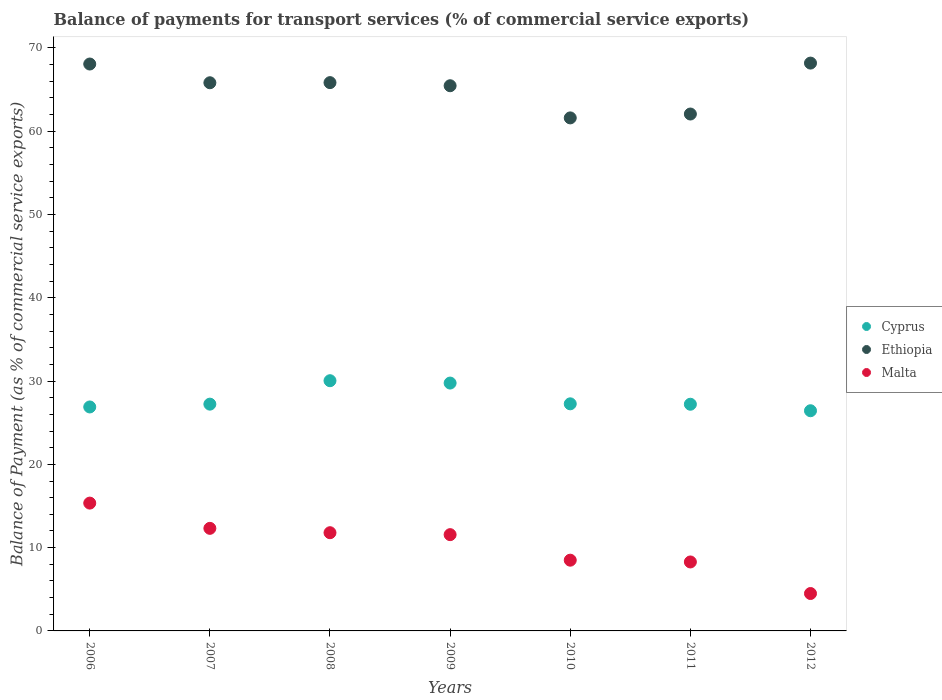How many different coloured dotlines are there?
Offer a very short reply. 3. What is the balance of payments for transport services in Malta in 2012?
Make the answer very short. 4.49. Across all years, what is the maximum balance of payments for transport services in Ethiopia?
Offer a very short reply. 68.18. Across all years, what is the minimum balance of payments for transport services in Ethiopia?
Your answer should be very brief. 61.6. In which year was the balance of payments for transport services in Malta maximum?
Offer a very short reply. 2006. What is the total balance of payments for transport services in Cyprus in the graph?
Keep it short and to the point. 194.86. What is the difference between the balance of payments for transport services in Malta in 2007 and that in 2008?
Your response must be concise. 0.52. What is the difference between the balance of payments for transport services in Malta in 2011 and the balance of payments for transport services in Ethiopia in 2012?
Give a very brief answer. -59.9. What is the average balance of payments for transport services in Ethiopia per year?
Make the answer very short. 65.29. In the year 2010, what is the difference between the balance of payments for transport services in Malta and balance of payments for transport services in Ethiopia?
Your answer should be very brief. -53.11. In how many years, is the balance of payments for transport services in Cyprus greater than 6 %?
Offer a terse response. 7. What is the ratio of the balance of payments for transport services in Cyprus in 2008 to that in 2010?
Provide a succinct answer. 1.1. Is the difference between the balance of payments for transport services in Malta in 2007 and 2011 greater than the difference between the balance of payments for transport services in Ethiopia in 2007 and 2011?
Make the answer very short. Yes. What is the difference between the highest and the second highest balance of payments for transport services in Ethiopia?
Provide a succinct answer. 0.11. What is the difference between the highest and the lowest balance of payments for transport services in Malta?
Provide a succinct answer. 10.86. Is the balance of payments for transport services in Malta strictly less than the balance of payments for transport services in Cyprus over the years?
Give a very brief answer. Yes. How many years are there in the graph?
Provide a short and direct response. 7. Does the graph contain any zero values?
Your answer should be compact. No. How are the legend labels stacked?
Your answer should be compact. Vertical. What is the title of the graph?
Ensure brevity in your answer.  Balance of payments for transport services (% of commercial service exports). Does "Botswana" appear as one of the legend labels in the graph?
Your answer should be very brief. No. What is the label or title of the X-axis?
Your answer should be compact. Years. What is the label or title of the Y-axis?
Your answer should be very brief. Balance of Payment (as % of commercial service exports). What is the Balance of Payment (as % of commercial service exports) in Cyprus in 2006?
Your answer should be compact. 26.89. What is the Balance of Payment (as % of commercial service exports) of Ethiopia in 2006?
Your answer should be very brief. 68.07. What is the Balance of Payment (as % of commercial service exports) in Malta in 2006?
Make the answer very short. 15.35. What is the Balance of Payment (as % of commercial service exports) in Cyprus in 2007?
Your answer should be compact. 27.23. What is the Balance of Payment (as % of commercial service exports) in Ethiopia in 2007?
Your answer should be very brief. 65.82. What is the Balance of Payment (as % of commercial service exports) in Malta in 2007?
Make the answer very short. 12.32. What is the Balance of Payment (as % of commercial service exports) in Cyprus in 2008?
Your answer should be compact. 30.05. What is the Balance of Payment (as % of commercial service exports) in Ethiopia in 2008?
Your answer should be compact. 65.84. What is the Balance of Payment (as % of commercial service exports) of Malta in 2008?
Offer a very short reply. 11.79. What is the Balance of Payment (as % of commercial service exports) in Cyprus in 2009?
Give a very brief answer. 29.76. What is the Balance of Payment (as % of commercial service exports) of Ethiopia in 2009?
Give a very brief answer. 65.47. What is the Balance of Payment (as % of commercial service exports) in Malta in 2009?
Keep it short and to the point. 11.56. What is the Balance of Payment (as % of commercial service exports) in Cyprus in 2010?
Keep it short and to the point. 27.27. What is the Balance of Payment (as % of commercial service exports) of Ethiopia in 2010?
Make the answer very short. 61.6. What is the Balance of Payment (as % of commercial service exports) in Malta in 2010?
Your answer should be compact. 8.49. What is the Balance of Payment (as % of commercial service exports) in Cyprus in 2011?
Give a very brief answer. 27.22. What is the Balance of Payment (as % of commercial service exports) in Ethiopia in 2011?
Your response must be concise. 62.07. What is the Balance of Payment (as % of commercial service exports) of Malta in 2011?
Provide a short and direct response. 8.28. What is the Balance of Payment (as % of commercial service exports) in Cyprus in 2012?
Ensure brevity in your answer.  26.44. What is the Balance of Payment (as % of commercial service exports) of Ethiopia in 2012?
Provide a short and direct response. 68.18. What is the Balance of Payment (as % of commercial service exports) of Malta in 2012?
Offer a very short reply. 4.49. Across all years, what is the maximum Balance of Payment (as % of commercial service exports) in Cyprus?
Keep it short and to the point. 30.05. Across all years, what is the maximum Balance of Payment (as % of commercial service exports) of Ethiopia?
Your answer should be very brief. 68.18. Across all years, what is the maximum Balance of Payment (as % of commercial service exports) of Malta?
Keep it short and to the point. 15.35. Across all years, what is the minimum Balance of Payment (as % of commercial service exports) of Cyprus?
Ensure brevity in your answer.  26.44. Across all years, what is the minimum Balance of Payment (as % of commercial service exports) of Ethiopia?
Give a very brief answer. 61.6. Across all years, what is the minimum Balance of Payment (as % of commercial service exports) of Malta?
Offer a very short reply. 4.49. What is the total Balance of Payment (as % of commercial service exports) of Cyprus in the graph?
Provide a succinct answer. 194.86. What is the total Balance of Payment (as % of commercial service exports) of Ethiopia in the graph?
Keep it short and to the point. 457.06. What is the total Balance of Payment (as % of commercial service exports) of Malta in the graph?
Provide a succinct answer. 72.29. What is the difference between the Balance of Payment (as % of commercial service exports) in Cyprus in 2006 and that in 2007?
Make the answer very short. -0.34. What is the difference between the Balance of Payment (as % of commercial service exports) in Ethiopia in 2006 and that in 2007?
Your answer should be very brief. 2.25. What is the difference between the Balance of Payment (as % of commercial service exports) of Malta in 2006 and that in 2007?
Offer a terse response. 3.03. What is the difference between the Balance of Payment (as % of commercial service exports) in Cyprus in 2006 and that in 2008?
Offer a very short reply. -3.15. What is the difference between the Balance of Payment (as % of commercial service exports) of Ethiopia in 2006 and that in 2008?
Your answer should be very brief. 2.23. What is the difference between the Balance of Payment (as % of commercial service exports) of Malta in 2006 and that in 2008?
Keep it short and to the point. 3.55. What is the difference between the Balance of Payment (as % of commercial service exports) in Cyprus in 2006 and that in 2009?
Make the answer very short. -2.87. What is the difference between the Balance of Payment (as % of commercial service exports) of Ethiopia in 2006 and that in 2009?
Your answer should be compact. 2.61. What is the difference between the Balance of Payment (as % of commercial service exports) in Malta in 2006 and that in 2009?
Keep it short and to the point. 3.79. What is the difference between the Balance of Payment (as % of commercial service exports) in Cyprus in 2006 and that in 2010?
Provide a short and direct response. -0.38. What is the difference between the Balance of Payment (as % of commercial service exports) in Ethiopia in 2006 and that in 2010?
Make the answer very short. 6.47. What is the difference between the Balance of Payment (as % of commercial service exports) of Malta in 2006 and that in 2010?
Your answer should be compact. 6.85. What is the difference between the Balance of Payment (as % of commercial service exports) in Cyprus in 2006 and that in 2011?
Provide a succinct answer. -0.33. What is the difference between the Balance of Payment (as % of commercial service exports) in Ethiopia in 2006 and that in 2011?
Give a very brief answer. 6. What is the difference between the Balance of Payment (as % of commercial service exports) of Malta in 2006 and that in 2011?
Your response must be concise. 7.07. What is the difference between the Balance of Payment (as % of commercial service exports) in Cyprus in 2006 and that in 2012?
Offer a very short reply. 0.45. What is the difference between the Balance of Payment (as % of commercial service exports) of Ethiopia in 2006 and that in 2012?
Provide a succinct answer. -0.11. What is the difference between the Balance of Payment (as % of commercial service exports) of Malta in 2006 and that in 2012?
Give a very brief answer. 10.86. What is the difference between the Balance of Payment (as % of commercial service exports) of Cyprus in 2007 and that in 2008?
Provide a short and direct response. -2.81. What is the difference between the Balance of Payment (as % of commercial service exports) of Ethiopia in 2007 and that in 2008?
Your answer should be very brief. -0.02. What is the difference between the Balance of Payment (as % of commercial service exports) in Malta in 2007 and that in 2008?
Provide a succinct answer. 0.52. What is the difference between the Balance of Payment (as % of commercial service exports) in Cyprus in 2007 and that in 2009?
Ensure brevity in your answer.  -2.53. What is the difference between the Balance of Payment (as % of commercial service exports) in Ethiopia in 2007 and that in 2009?
Keep it short and to the point. 0.36. What is the difference between the Balance of Payment (as % of commercial service exports) of Malta in 2007 and that in 2009?
Provide a short and direct response. 0.76. What is the difference between the Balance of Payment (as % of commercial service exports) in Cyprus in 2007 and that in 2010?
Offer a terse response. -0.04. What is the difference between the Balance of Payment (as % of commercial service exports) of Ethiopia in 2007 and that in 2010?
Ensure brevity in your answer.  4.22. What is the difference between the Balance of Payment (as % of commercial service exports) of Malta in 2007 and that in 2010?
Provide a short and direct response. 3.82. What is the difference between the Balance of Payment (as % of commercial service exports) of Cyprus in 2007 and that in 2011?
Your answer should be very brief. 0.01. What is the difference between the Balance of Payment (as % of commercial service exports) of Ethiopia in 2007 and that in 2011?
Provide a short and direct response. 3.75. What is the difference between the Balance of Payment (as % of commercial service exports) in Malta in 2007 and that in 2011?
Your response must be concise. 4.04. What is the difference between the Balance of Payment (as % of commercial service exports) in Cyprus in 2007 and that in 2012?
Give a very brief answer. 0.79. What is the difference between the Balance of Payment (as % of commercial service exports) of Ethiopia in 2007 and that in 2012?
Offer a terse response. -2.36. What is the difference between the Balance of Payment (as % of commercial service exports) in Malta in 2007 and that in 2012?
Keep it short and to the point. 7.83. What is the difference between the Balance of Payment (as % of commercial service exports) of Cyprus in 2008 and that in 2009?
Your answer should be compact. 0.28. What is the difference between the Balance of Payment (as % of commercial service exports) in Ethiopia in 2008 and that in 2009?
Offer a terse response. 0.37. What is the difference between the Balance of Payment (as % of commercial service exports) of Malta in 2008 and that in 2009?
Keep it short and to the point. 0.23. What is the difference between the Balance of Payment (as % of commercial service exports) in Cyprus in 2008 and that in 2010?
Your answer should be very brief. 2.78. What is the difference between the Balance of Payment (as % of commercial service exports) in Ethiopia in 2008 and that in 2010?
Provide a succinct answer. 4.24. What is the difference between the Balance of Payment (as % of commercial service exports) in Malta in 2008 and that in 2010?
Make the answer very short. 3.3. What is the difference between the Balance of Payment (as % of commercial service exports) in Cyprus in 2008 and that in 2011?
Your answer should be compact. 2.83. What is the difference between the Balance of Payment (as % of commercial service exports) of Ethiopia in 2008 and that in 2011?
Keep it short and to the point. 3.77. What is the difference between the Balance of Payment (as % of commercial service exports) of Malta in 2008 and that in 2011?
Your answer should be compact. 3.51. What is the difference between the Balance of Payment (as % of commercial service exports) of Cyprus in 2008 and that in 2012?
Offer a terse response. 3.61. What is the difference between the Balance of Payment (as % of commercial service exports) of Ethiopia in 2008 and that in 2012?
Ensure brevity in your answer.  -2.34. What is the difference between the Balance of Payment (as % of commercial service exports) of Malta in 2008 and that in 2012?
Provide a short and direct response. 7.3. What is the difference between the Balance of Payment (as % of commercial service exports) of Cyprus in 2009 and that in 2010?
Provide a succinct answer. 2.49. What is the difference between the Balance of Payment (as % of commercial service exports) of Ethiopia in 2009 and that in 2010?
Provide a succinct answer. 3.86. What is the difference between the Balance of Payment (as % of commercial service exports) of Malta in 2009 and that in 2010?
Give a very brief answer. 3.07. What is the difference between the Balance of Payment (as % of commercial service exports) of Cyprus in 2009 and that in 2011?
Offer a terse response. 2.54. What is the difference between the Balance of Payment (as % of commercial service exports) of Ethiopia in 2009 and that in 2011?
Provide a short and direct response. 3.4. What is the difference between the Balance of Payment (as % of commercial service exports) in Malta in 2009 and that in 2011?
Provide a short and direct response. 3.28. What is the difference between the Balance of Payment (as % of commercial service exports) in Cyprus in 2009 and that in 2012?
Your answer should be compact. 3.32. What is the difference between the Balance of Payment (as % of commercial service exports) in Ethiopia in 2009 and that in 2012?
Make the answer very short. -2.72. What is the difference between the Balance of Payment (as % of commercial service exports) in Malta in 2009 and that in 2012?
Provide a short and direct response. 7.07. What is the difference between the Balance of Payment (as % of commercial service exports) in Cyprus in 2010 and that in 2011?
Offer a very short reply. 0.05. What is the difference between the Balance of Payment (as % of commercial service exports) of Ethiopia in 2010 and that in 2011?
Offer a terse response. -0.46. What is the difference between the Balance of Payment (as % of commercial service exports) of Malta in 2010 and that in 2011?
Your answer should be very brief. 0.21. What is the difference between the Balance of Payment (as % of commercial service exports) in Cyprus in 2010 and that in 2012?
Your answer should be very brief. 0.83. What is the difference between the Balance of Payment (as % of commercial service exports) in Ethiopia in 2010 and that in 2012?
Your answer should be very brief. -6.58. What is the difference between the Balance of Payment (as % of commercial service exports) of Malta in 2010 and that in 2012?
Ensure brevity in your answer.  4. What is the difference between the Balance of Payment (as % of commercial service exports) in Cyprus in 2011 and that in 2012?
Ensure brevity in your answer.  0.78. What is the difference between the Balance of Payment (as % of commercial service exports) of Ethiopia in 2011 and that in 2012?
Ensure brevity in your answer.  -6.12. What is the difference between the Balance of Payment (as % of commercial service exports) of Malta in 2011 and that in 2012?
Provide a short and direct response. 3.79. What is the difference between the Balance of Payment (as % of commercial service exports) of Cyprus in 2006 and the Balance of Payment (as % of commercial service exports) of Ethiopia in 2007?
Give a very brief answer. -38.93. What is the difference between the Balance of Payment (as % of commercial service exports) in Cyprus in 2006 and the Balance of Payment (as % of commercial service exports) in Malta in 2007?
Provide a short and direct response. 14.58. What is the difference between the Balance of Payment (as % of commercial service exports) in Ethiopia in 2006 and the Balance of Payment (as % of commercial service exports) in Malta in 2007?
Ensure brevity in your answer.  55.76. What is the difference between the Balance of Payment (as % of commercial service exports) of Cyprus in 2006 and the Balance of Payment (as % of commercial service exports) of Ethiopia in 2008?
Your answer should be very brief. -38.95. What is the difference between the Balance of Payment (as % of commercial service exports) in Cyprus in 2006 and the Balance of Payment (as % of commercial service exports) in Malta in 2008?
Provide a short and direct response. 15.1. What is the difference between the Balance of Payment (as % of commercial service exports) of Ethiopia in 2006 and the Balance of Payment (as % of commercial service exports) of Malta in 2008?
Offer a terse response. 56.28. What is the difference between the Balance of Payment (as % of commercial service exports) in Cyprus in 2006 and the Balance of Payment (as % of commercial service exports) in Ethiopia in 2009?
Provide a succinct answer. -38.57. What is the difference between the Balance of Payment (as % of commercial service exports) of Cyprus in 2006 and the Balance of Payment (as % of commercial service exports) of Malta in 2009?
Offer a terse response. 15.33. What is the difference between the Balance of Payment (as % of commercial service exports) of Ethiopia in 2006 and the Balance of Payment (as % of commercial service exports) of Malta in 2009?
Offer a terse response. 56.51. What is the difference between the Balance of Payment (as % of commercial service exports) in Cyprus in 2006 and the Balance of Payment (as % of commercial service exports) in Ethiopia in 2010?
Your response must be concise. -34.71. What is the difference between the Balance of Payment (as % of commercial service exports) in Cyprus in 2006 and the Balance of Payment (as % of commercial service exports) in Malta in 2010?
Offer a very short reply. 18.4. What is the difference between the Balance of Payment (as % of commercial service exports) of Ethiopia in 2006 and the Balance of Payment (as % of commercial service exports) of Malta in 2010?
Keep it short and to the point. 59.58. What is the difference between the Balance of Payment (as % of commercial service exports) in Cyprus in 2006 and the Balance of Payment (as % of commercial service exports) in Ethiopia in 2011?
Offer a very short reply. -35.18. What is the difference between the Balance of Payment (as % of commercial service exports) in Cyprus in 2006 and the Balance of Payment (as % of commercial service exports) in Malta in 2011?
Your answer should be compact. 18.61. What is the difference between the Balance of Payment (as % of commercial service exports) in Ethiopia in 2006 and the Balance of Payment (as % of commercial service exports) in Malta in 2011?
Give a very brief answer. 59.79. What is the difference between the Balance of Payment (as % of commercial service exports) in Cyprus in 2006 and the Balance of Payment (as % of commercial service exports) in Ethiopia in 2012?
Give a very brief answer. -41.29. What is the difference between the Balance of Payment (as % of commercial service exports) in Cyprus in 2006 and the Balance of Payment (as % of commercial service exports) in Malta in 2012?
Your response must be concise. 22.4. What is the difference between the Balance of Payment (as % of commercial service exports) in Ethiopia in 2006 and the Balance of Payment (as % of commercial service exports) in Malta in 2012?
Give a very brief answer. 63.58. What is the difference between the Balance of Payment (as % of commercial service exports) in Cyprus in 2007 and the Balance of Payment (as % of commercial service exports) in Ethiopia in 2008?
Offer a very short reply. -38.61. What is the difference between the Balance of Payment (as % of commercial service exports) of Cyprus in 2007 and the Balance of Payment (as % of commercial service exports) of Malta in 2008?
Offer a very short reply. 15.44. What is the difference between the Balance of Payment (as % of commercial service exports) of Ethiopia in 2007 and the Balance of Payment (as % of commercial service exports) of Malta in 2008?
Give a very brief answer. 54.03. What is the difference between the Balance of Payment (as % of commercial service exports) in Cyprus in 2007 and the Balance of Payment (as % of commercial service exports) in Ethiopia in 2009?
Your answer should be compact. -38.23. What is the difference between the Balance of Payment (as % of commercial service exports) of Cyprus in 2007 and the Balance of Payment (as % of commercial service exports) of Malta in 2009?
Your answer should be compact. 15.67. What is the difference between the Balance of Payment (as % of commercial service exports) of Ethiopia in 2007 and the Balance of Payment (as % of commercial service exports) of Malta in 2009?
Your answer should be very brief. 54.26. What is the difference between the Balance of Payment (as % of commercial service exports) of Cyprus in 2007 and the Balance of Payment (as % of commercial service exports) of Ethiopia in 2010?
Make the answer very short. -34.37. What is the difference between the Balance of Payment (as % of commercial service exports) of Cyprus in 2007 and the Balance of Payment (as % of commercial service exports) of Malta in 2010?
Your response must be concise. 18.74. What is the difference between the Balance of Payment (as % of commercial service exports) in Ethiopia in 2007 and the Balance of Payment (as % of commercial service exports) in Malta in 2010?
Give a very brief answer. 57.33. What is the difference between the Balance of Payment (as % of commercial service exports) of Cyprus in 2007 and the Balance of Payment (as % of commercial service exports) of Ethiopia in 2011?
Provide a succinct answer. -34.84. What is the difference between the Balance of Payment (as % of commercial service exports) in Cyprus in 2007 and the Balance of Payment (as % of commercial service exports) in Malta in 2011?
Keep it short and to the point. 18.95. What is the difference between the Balance of Payment (as % of commercial service exports) of Ethiopia in 2007 and the Balance of Payment (as % of commercial service exports) of Malta in 2011?
Keep it short and to the point. 57.54. What is the difference between the Balance of Payment (as % of commercial service exports) of Cyprus in 2007 and the Balance of Payment (as % of commercial service exports) of Ethiopia in 2012?
Keep it short and to the point. -40.95. What is the difference between the Balance of Payment (as % of commercial service exports) of Cyprus in 2007 and the Balance of Payment (as % of commercial service exports) of Malta in 2012?
Make the answer very short. 22.74. What is the difference between the Balance of Payment (as % of commercial service exports) of Ethiopia in 2007 and the Balance of Payment (as % of commercial service exports) of Malta in 2012?
Give a very brief answer. 61.33. What is the difference between the Balance of Payment (as % of commercial service exports) of Cyprus in 2008 and the Balance of Payment (as % of commercial service exports) of Ethiopia in 2009?
Provide a short and direct response. -35.42. What is the difference between the Balance of Payment (as % of commercial service exports) in Cyprus in 2008 and the Balance of Payment (as % of commercial service exports) in Malta in 2009?
Your response must be concise. 18.48. What is the difference between the Balance of Payment (as % of commercial service exports) in Ethiopia in 2008 and the Balance of Payment (as % of commercial service exports) in Malta in 2009?
Offer a terse response. 54.28. What is the difference between the Balance of Payment (as % of commercial service exports) of Cyprus in 2008 and the Balance of Payment (as % of commercial service exports) of Ethiopia in 2010?
Ensure brevity in your answer.  -31.56. What is the difference between the Balance of Payment (as % of commercial service exports) in Cyprus in 2008 and the Balance of Payment (as % of commercial service exports) in Malta in 2010?
Keep it short and to the point. 21.55. What is the difference between the Balance of Payment (as % of commercial service exports) of Ethiopia in 2008 and the Balance of Payment (as % of commercial service exports) of Malta in 2010?
Make the answer very short. 57.35. What is the difference between the Balance of Payment (as % of commercial service exports) of Cyprus in 2008 and the Balance of Payment (as % of commercial service exports) of Ethiopia in 2011?
Keep it short and to the point. -32.02. What is the difference between the Balance of Payment (as % of commercial service exports) in Cyprus in 2008 and the Balance of Payment (as % of commercial service exports) in Malta in 2011?
Your answer should be compact. 21.76. What is the difference between the Balance of Payment (as % of commercial service exports) in Ethiopia in 2008 and the Balance of Payment (as % of commercial service exports) in Malta in 2011?
Keep it short and to the point. 57.56. What is the difference between the Balance of Payment (as % of commercial service exports) in Cyprus in 2008 and the Balance of Payment (as % of commercial service exports) in Ethiopia in 2012?
Ensure brevity in your answer.  -38.14. What is the difference between the Balance of Payment (as % of commercial service exports) in Cyprus in 2008 and the Balance of Payment (as % of commercial service exports) in Malta in 2012?
Ensure brevity in your answer.  25.55. What is the difference between the Balance of Payment (as % of commercial service exports) of Ethiopia in 2008 and the Balance of Payment (as % of commercial service exports) of Malta in 2012?
Provide a short and direct response. 61.35. What is the difference between the Balance of Payment (as % of commercial service exports) of Cyprus in 2009 and the Balance of Payment (as % of commercial service exports) of Ethiopia in 2010?
Provide a succinct answer. -31.84. What is the difference between the Balance of Payment (as % of commercial service exports) of Cyprus in 2009 and the Balance of Payment (as % of commercial service exports) of Malta in 2010?
Provide a succinct answer. 21.27. What is the difference between the Balance of Payment (as % of commercial service exports) of Ethiopia in 2009 and the Balance of Payment (as % of commercial service exports) of Malta in 2010?
Offer a terse response. 56.97. What is the difference between the Balance of Payment (as % of commercial service exports) of Cyprus in 2009 and the Balance of Payment (as % of commercial service exports) of Ethiopia in 2011?
Give a very brief answer. -32.31. What is the difference between the Balance of Payment (as % of commercial service exports) in Cyprus in 2009 and the Balance of Payment (as % of commercial service exports) in Malta in 2011?
Ensure brevity in your answer.  21.48. What is the difference between the Balance of Payment (as % of commercial service exports) of Ethiopia in 2009 and the Balance of Payment (as % of commercial service exports) of Malta in 2011?
Your answer should be compact. 57.18. What is the difference between the Balance of Payment (as % of commercial service exports) in Cyprus in 2009 and the Balance of Payment (as % of commercial service exports) in Ethiopia in 2012?
Offer a terse response. -38.42. What is the difference between the Balance of Payment (as % of commercial service exports) of Cyprus in 2009 and the Balance of Payment (as % of commercial service exports) of Malta in 2012?
Keep it short and to the point. 25.27. What is the difference between the Balance of Payment (as % of commercial service exports) of Ethiopia in 2009 and the Balance of Payment (as % of commercial service exports) of Malta in 2012?
Your response must be concise. 60.97. What is the difference between the Balance of Payment (as % of commercial service exports) in Cyprus in 2010 and the Balance of Payment (as % of commercial service exports) in Ethiopia in 2011?
Make the answer very short. -34.8. What is the difference between the Balance of Payment (as % of commercial service exports) in Cyprus in 2010 and the Balance of Payment (as % of commercial service exports) in Malta in 2011?
Your response must be concise. 18.99. What is the difference between the Balance of Payment (as % of commercial service exports) of Ethiopia in 2010 and the Balance of Payment (as % of commercial service exports) of Malta in 2011?
Make the answer very short. 53.32. What is the difference between the Balance of Payment (as % of commercial service exports) in Cyprus in 2010 and the Balance of Payment (as % of commercial service exports) in Ethiopia in 2012?
Ensure brevity in your answer.  -40.91. What is the difference between the Balance of Payment (as % of commercial service exports) in Cyprus in 2010 and the Balance of Payment (as % of commercial service exports) in Malta in 2012?
Offer a very short reply. 22.78. What is the difference between the Balance of Payment (as % of commercial service exports) in Ethiopia in 2010 and the Balance of Payment (as % of commercial service exports) in Malta in 2012?
Give a very brief answer. 57.11. What is the difference between the Balance of Payment (as % of commercial service exports) of Cyprus in 2011 and the Balance of Payment (as % of commercial service exports) of Ethiopia in 2012?
Keep it short and to the point. -40.96. What is the difference between the Balance of Payment (as % of commercial service exports) in Cyprus in 2011 and the Balance of Payment (as % of commercial service exports) in Malta in 2012?
Offer a terse response. 22.73. What is the difference between the Balance of Payment (as % of commercial service exports) of Ethiopia in 2011 and the Balance of Payment (as % of commercial service exports) of Malta in 2012?
Your response must be concise. 57.58. What is the average Balance of Payment (as % of commercial service exports) in Cyprus per year?
Your response must be concise. 27.84. What is the average Balance of Payment (as % of commercial service exports) in Ethiopia per year?
Offer a terse response. 65.29. What is the average Balance of Payment (as % of commercial service exports) of Malta per year?
Keep it short and to the point. 10.33. In the year 2006, what is the difference between the Balance of Payment (as % of commercial service exports) in Cyprus and Balance of Payment (as % of commercial service exports) in Ethiopia?
Offer a terse response. -41.18. In the year 2006, what is the difference between the Balance of Payment (as % of commercial service exports) in Cyprus and Balance of Payment (as % of commercial service exports) in Malta?
Your response must be concise. 11.55. In the year 2006, what is the difference between the Balance of Payment (as % of commercial service exports) of Ethiopia and Balance of Payment (as % of commercial service exports) of Malta?
Your response must be concise. 52.73. In the year 2007, what is the difference between the Balance of Payment (as % of commercial service exports) of Cyprus and Balance of Payment (as % of commercial service exports) of Ethiopia?
Make the answer very short. -38.59. In the year 2007, what is the difference between the Balance of Payment (as % of commercial service exports) of Cyprus and Balance of Payment (as % of commercial service exports) of Malta?
Offer a terse response. 14.91. In the year 2007, what is the difference between the Balance of Payment (as % of commercial service exports) of Ethiopia and Balance of Payment (as % of commercial service exports) of Malta?
Your answer should be compact. 53.51. In the year 2008, what is the difference between the Balance of Payment (as % of commercial service exports) of Cyprus and Balance of Payment (as % of commercial service exports) of Ethiopia?
Your answer should be very brief. -35.79. In the year 2008, what is the difference between the Balance of Payment (as % of commercial service exports) of Cyprus and Balance of Payment (as % of commercial service exports) of Malta?
Keep it short and to the point. 18.25. In the year 2008, what is the difference between the Balance of Payment (as % of commercial service exports) of Ethiopia and Balance of Payment (as % of commercial service exports) of Malta?
Offer a very short reply. 54.05. In the year 2009, what is the difference between the Balance of Payment (as % of commercial service exports) in Cyprus and Balance of Payment (as % of commercial service exports) in Ethiopia?
Give a very brief answer. -35.7. In the year 2009, what is the difference between the Balance of Payment (as % of commercial service exports) of Cyprus and Balance of Payment (as % of commercial service exports) of Malta?
Give a very brief answer. 18.2. In the year 2009, what is the difference between the Balance of Payment (as % of commercial service exports) in Ethiopia and Balance of Payment (as % of commercial service exports) in Malta?
Give a very brief answer. 53.91. In the year 2010, what is the difference between the Balance of Payment (as % of commercial service exports) in Cyprus and Balance of Payment (as % of commercial service exports) in Ethiopia?
Provide a succinct answer. -34.33. In the year 2010, what is the difference between the Balance of Payment (as % of commercial service exports) of Cyprus and Balance of Payment (as % of commercial service exports) of Malta?
Provide a succinct answer. 18.78. In the year 2010, what is the difference between the Balance of Payment (as % of commercial service exports) in Ethiopia and Balance of Payment (as % of commercial service exports) in Malta?
Offer a very short reply. 53.11. In the year 2011, what is the difference between the Balance of Payment (as % of commercial service exports) of Cyprus and Balance of Payment (as % of commercial service exports) of Ethiopia?
Offer a terse response. -34.85. In the year 2011, what is the difference between the Balance of Payment (as % of commercial service exports) in Cyprus and Balance of Payment (as % of commercial service exports) in Malta?
Provide a short and direct response. 18.94. In the year 2011, what is the difference between the Balance of Payment (as % of commercial service exports) of Ethiopia and Balance of Payment (as % of commercial service exports) of Malta?
Keep it short and to the point. 53.79. In the year 2012, what is the difference between the Balance of Payment (as % of commercial service exports) in Cyprus and Balance of Payment (as % of commercial service exports) in Ethiopia?
Your answer should be compact. -41.75. In the year 2012, what is the difference between the Balance of Payment (as % of commercial service exports) in Cyprus and Balance of Payment (as % of commercial service exports) in Malta?
Offer a very short reply. 21.95. In the year 2012, what is the difference between the Balance of Payment (as % of commercial service exports) in Ethiopia and Balance of Payment (as % of commercial service exports) in Malta?
Keep it short and to the point. 63.69. What is the ratio of the Balance of Payment (as % of commercial service exports) of Cyprus in 2006 to that in 2007?
Make the answer very short. 0.99. What is the ratio of the Balance of Payment (as % of commercial service exports) in Ethiopia in 2006 to that in 2007?
Offer a very short reply. 1.03. What is the ratio of the Balance of Payment (as % of commercial service exports) in Malta in 2006 to that in 2007?
Your response must be concise. 1.25. What is the ratio of the Balance of Payment (as % of commercial service exports) of Cyprus in 2006 to that in 2008?
Provide a short and direct response. 0.9. What is the ratio of the Balance of Payment (as % of commercial service exports) in Ethiopia in 2006 to that in 2008?
Ensure brevity in your answer.  1.03. What is the ratio of the Balance of Payment (as % of commercial service exports) in Malta in 2006 to that in 2008?
Offer a terse response. 1.3. What is the ratio of the Balance of Payment (as % of commercial service exports) of Cyprus in 2006 to that in 2009?
Your answer should be very brief. 0.9. What is the ratio of the Balance of Payment (as % of commercial service exports) in Ethiopia in 2006 to that in 2009?
Ensure brevity in your answer.  1.04. What is the ratio of the Balance of Payment (as % of commercial service exports) in Malta in 2006 to that in 2009?
Your response must be concise. 1.33. What is the ratio of the Balance of Payment (as % of commercial service exports) of Cyprus in 2006 to that in 2010?
Provide a succinct answer. 0.99. What is the ratio of the Balance of Payment (as % of commercial service exports) in Ethiopia in 2006 to that in 2010?
Offer a terse response. 1.1. What is the ratio of the Balance of Payment (as % of commercial service exports) of Malta in 2006 to that in 2010?
Your answer should be compact. 1.81. What is the ratio of the Balance of Payment (as % of commercial service exports) in Ethiopia in 2006 to that in 2011?
Ensure brevity in your answer.  1.1. What is the ratio of the Balance of Payment (as % of commercial service exports) of Malta in 2006 to that in 2011?
Give a very brief answer. 1.85. What is the ratio of the Balance of Payment (as % of commercial service exports) in Cyprus in 2006 to that in 2012?
Provide a short and direct response. 1.02. What is the ratio of the Balance of Payment (as % of commercial service exports) in Ethiopia in 2006 to that in 2012?
Make the answer very short. 1. What is the ratio of the Balance of Payment (as % of commercial service exports) in Malta in 2006 to that in 2012?
Offer a terse response. 3.42. What is the ratio of the Balance of Payment (as % of commercial service exports) in Cyprus in 2007 to that in 2008?
Provide a short and direct response. 0.91. What is the ratio of the Balance of Payment (as % of commercial service exports) in Ethiopia in 2007 to that in 2008?
Ensure brevity in your answer.  1. What is the ratio of the Balance of Payment (as % of commercial service exports) in Malta in 2007 to that in 2008?
Keep it short and to the point. 1.04. What is the ratio of the Balance of Payment (as % of commercial service exports) in Cyprus in 2007 to that in 2009?
Give a very brief answer. 0.91. What is the ratio of the Balance of Payment (as % of commercial service exports) of Malta in 2007 to that in 2009?
Provide a short and direct response. 1.07. What is the ratio of the Balance of Payment (as % of commercial service exports) in Ethiopia in 2007 to that in 2010?
Your answer should be very brief. 1.07. What is the ratio of the Balance of Payment (as % of commercial service exports) of Malta in 2007 to that in 2010?
Keep it short and to the point. 1.45. What is the ratio of the Balance of Payment (as % of commercial service exports) in Cyprus in 2007 to that in 2011?
Your answer should be compact. 1. What is the ratio of the Balance of Payment (as % of commercial service exports) of Ethiopia in 2007 to that in 2011?
Ensure brevity in your answer.  1.06. What is the ratio of the Balance of Payment (as % of commercial service exports) in Malta in 2007 to that in 2011?
Ensure brevity in your answer.  1.49. What is the ratio of the Balance of Payment (as % of commercial service exports) of Cyprus in 2007 to that in 2012?
Make the answer very short. 1.03. What is the ratio of the Balance of Payment (as % of commercial service exports) of Ethiopia in 2007 to that in 2012?
Your answer should be compact. 0.97. What is the ratio of the Balance of Payment (as % of commercial service exports) in Malta in 2007 to that in 2012?
Provide a succinct answer. 2.74. What is the ratio of the Balance of Payment (as % of commercial service exports) of Cyprus in 2008 to that in 2009?
Provide a short and direct response. 1.01. What is the ratio of the Balance of Payment (as % of commercial service exports) of Malta in 2008 to that in 2009?
Keep it short and to the point. 1.02. What is the ratio of the Balance of Payment (as % of commercial service exports) of Cyprus in 2008 to that in 2010?
Your answer should be compact. 1.1. What is the ratio of the Balance of Payment (as % of commercial service exports) of Ethiopia in 2008 to that in 2010?
Give a very brief answer. 1.07. What is the ratio of the Balance of Payment (as % of commercial service exports) of Malta in 2008 to that in 2010?
Provide a short and direct response. 1.39. What is the ratio of the Balance of Payment (as % of commercial service exports) of Cyprus in 2008 to that in 2011?
Ensure brevity in your answer.  1.1. What is the ratio of the Balance of Payment (as % of commercial service exports) in Ethiopia in 2008 to that in 2011?
Provide a short and direct response. 1.06. What is the ratio of the Balance of Payment (as % of commercial service exports) of Malta in 2008 to that in 2011?
Your answer should be compact. 1.42. What is the ratio of the Balance of Payment (as % of commercial service exports) in Cyprus in 2008 to that in 2012?
Provide a short and direct response. 1.14. What is the ratio of the Balance of Payment (as % of commercial service exports) in Ethiopia in 2008 to that in 2012?
Your answer should be compact. 0.97. What is the ratio of the Balance of Payment (as % of commercial service exports) of Malta in 2008 to that in 2012?
Make the answer very short. 2.63. What is the ratio of the Balance of Payment (as % of commercial service exports) in Cyprus in 2009 to that in 2010?
Keep it short and to the point. 1.09. What is the ratio of the Balance of Payment (as % of commercial service exports) of Ethiopia in 2009 to that in 2010?
Provide a short and direct response. 1.06. What is the ratio of the Balance of Payment (as % of commercial service exports) in Malta in 2009 to that in 2010?
Your answer should be very brief. 1.36. What is the ratio of the Balance of Payment (as % of commercial service exports) of Cyprus in 2009 to that in 2011?
Offer a very short reply. 1.09. What is the ratio of the Balance of Payment (as % of commercial service exports) in Ethiopia in 2009 to that in 2011?
Make the answer very short. 1.05. What is the ratio of the Balance of Payment (as % of commercial service exports) in Malta in 2009 to that in 2011?
Offer a very short reply. 1.4. What is the ratio of the Balance of Payment (as % of commercial service exports) of Cyprus in 2009 to that in 2012?
Give a very brief answer. 1.13. What is the ratio of the Balance of Payment (as % of commercial service exports) in Ethiopia in 2009 to that in 2012?
Ensure brevity in your answer.  0.96. What is the ratio of the Balance of Payment (as % of commercial service exports) of Malta in 2009 to that in 2012?
Offer a terse response. 2.57. What is the ratio of the Balance of Payment (as % of commercial service exports) of Ethiopia in 2010 to that in 2011?
Offer a very short reply. 0.99. What is the ratio of the Balance of Payment (as % of commercial service exports) in Malta in 2010 to that in 2011?
Give a very brief answer. 1.03. What is the ratio of the Balance of Payment (as % of commercial service exports) in Cyprus in 2010 to that in 2012?
Provide a succinct answer. 1.03. What is the ratio of the Balance of Payment (as % of commercial service exports) in Ethiopia in 2010 to that in 2012?
Offer a terse response. 0.9. What is the ratio of the Balance of Payment (as % of commercial service exports) in Malta in 2010 to that in 2012?
Offer a very short reply. 1.89. What is the ratio of the Balance of Payment (as % of commercial service exports) in Cyprus in 2011 to that in 2012?
Keep it short and to the point. 1.03. What is the ratio of the Balance of Payment (as % of commercial service exports) in Ethiopia in 2011 to that in 2012?
Offer a terse response. 0.91. What is the ratio of the Balance of Payment (as % of commercial service exports) of Malta in 2011 to that in 2012?
Your answer should be very brief. 1.84. What is the difference between the highest and the second highest Balance of Payment (as % of commercial service exports) in Cyprus?
Provide a short and direct response. 0.28. What is the difference between the highest and the second highest Balance of Payment (as % of commercial service exports) of Malta?
Offer a very short reply. 3.03. What is the difference between the highest and the lowest Balance of Payment (as % of commercial service exports) of Cyprus?
Provide a succinct answer. 3.61. What is the difference between the highest and the lowest Balance of Payment (as % of commercial service exports) of Ethiopia?
Give a very brief answer. 6.58. What is the difference between the highest and the lowest Balance of Payment (as % of commercial service exports) in Malta?
Ensure brevity in your answer.  10.86. 